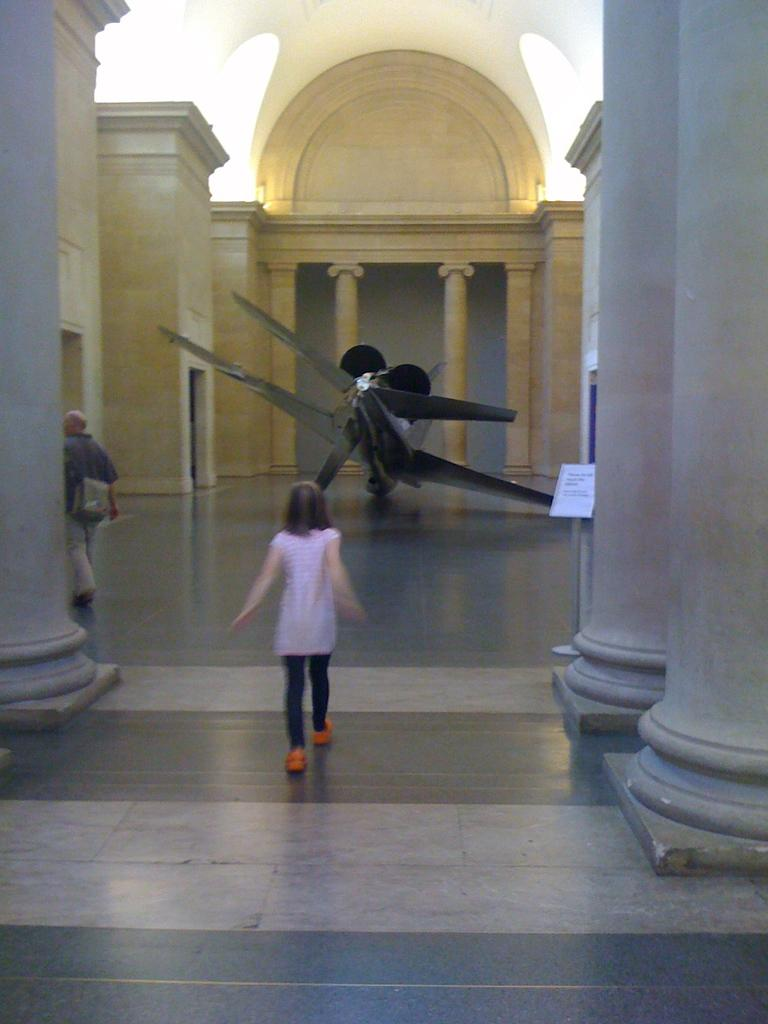What is the girl doing in the image? The girl is walking in the image. Can you describe the person on the left side of the image? There is a person walking on the left side of the image. What architectural feature can be seen in the image? There are pillars visible in the image. What type of dress is the girl wearing in the church? There is no mention of a church or a dress in the image, so we cannot answer this question. 